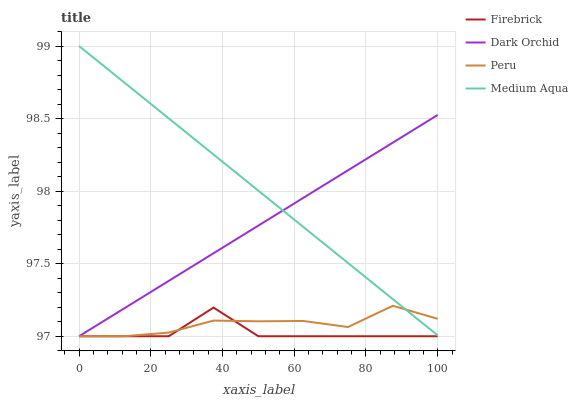Does Firebrick have the minimum area under the curve?
Answer yes or no. Yes. Does Medium Aqua have the maximum area under the curve?
Answer yes or no. Yes. Does Peru have the minimum area under the curve?
Answer yes or no. No. Does Peru have the maximum area under the curve?
Answer yes or no. No. Is Dark Orchid the smoothest?
Answer yes or no. Yes. Is Firebrick the roughest?
Answer yes or no. Yes. Is Medium Aqua the smoothest?
Answer yes or no. No. Is Medium Aqua the roughest?
Answer yes or no. No. Does Medium Aqua have the lowest value?
Answer yes or no. No. Does Medium Aqua have the highest value?
Answer yes or no. Yes. Does Peru have the highest value?
Answer yes or no. No. Is Firebrick less than Medium Aqua?
Answer yes or no. Yes. Is Medium Aqua greater than Firebrick?
Answer yes or no. Yes. Does Peru intersect Dark Orchid?
Answer yes or no. Yes. Is Peru less than Dark Orchid?
Answer yes or no. No. Is Peru greater than Dark Orchid?
Answer yes or no. No. Does Firebrick intersect Medium Aqua?
Answer yes or no. No. 